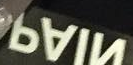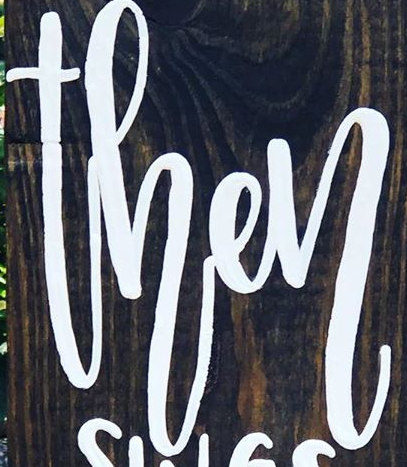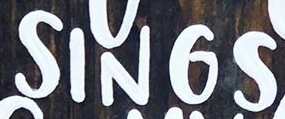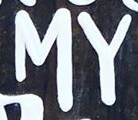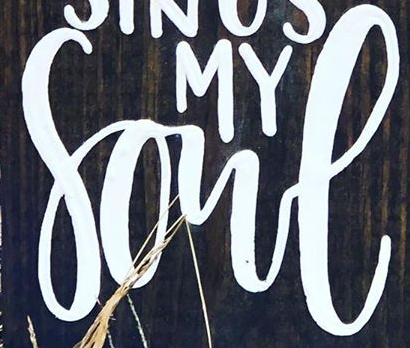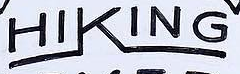What text is displayed in these images sequentially, separated by a semicolon? NIAP; then; SINGS; MY; Sone; HIKING 